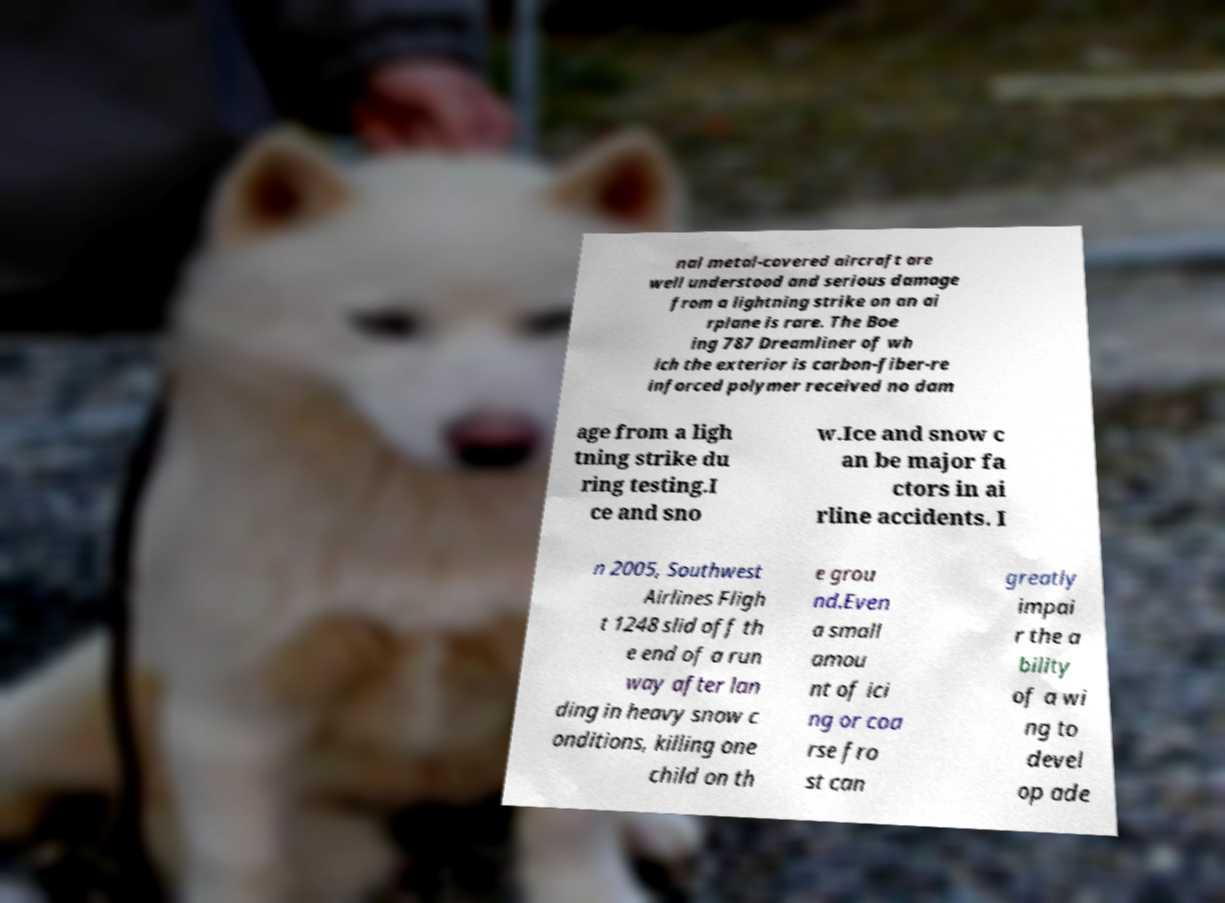What messages or text are displayed in this image? I need them in a readable, typed format. nal metal-covered aircraft are well understood and serious damage from a lightning strike on an ai rplane is rare. The Boe ing 787 Dreamliner of wh ich the exterior is carbon-fiber-re inforced polymer received no dam age from a ligh tning strike du ring testing.I ce and sno w.Ice and snow c an be major fa ctors in ai rline accidents. I n 2005, Southwest Airlines Fligh t 1248 slid off th e end of a run way after lan ding in heavy snow c onditions, killing one child on th e grou nd.Even a small amou nt of ici ng or coa rse fro st can greatly impai r the a bility of a wi ng to devel op ade 